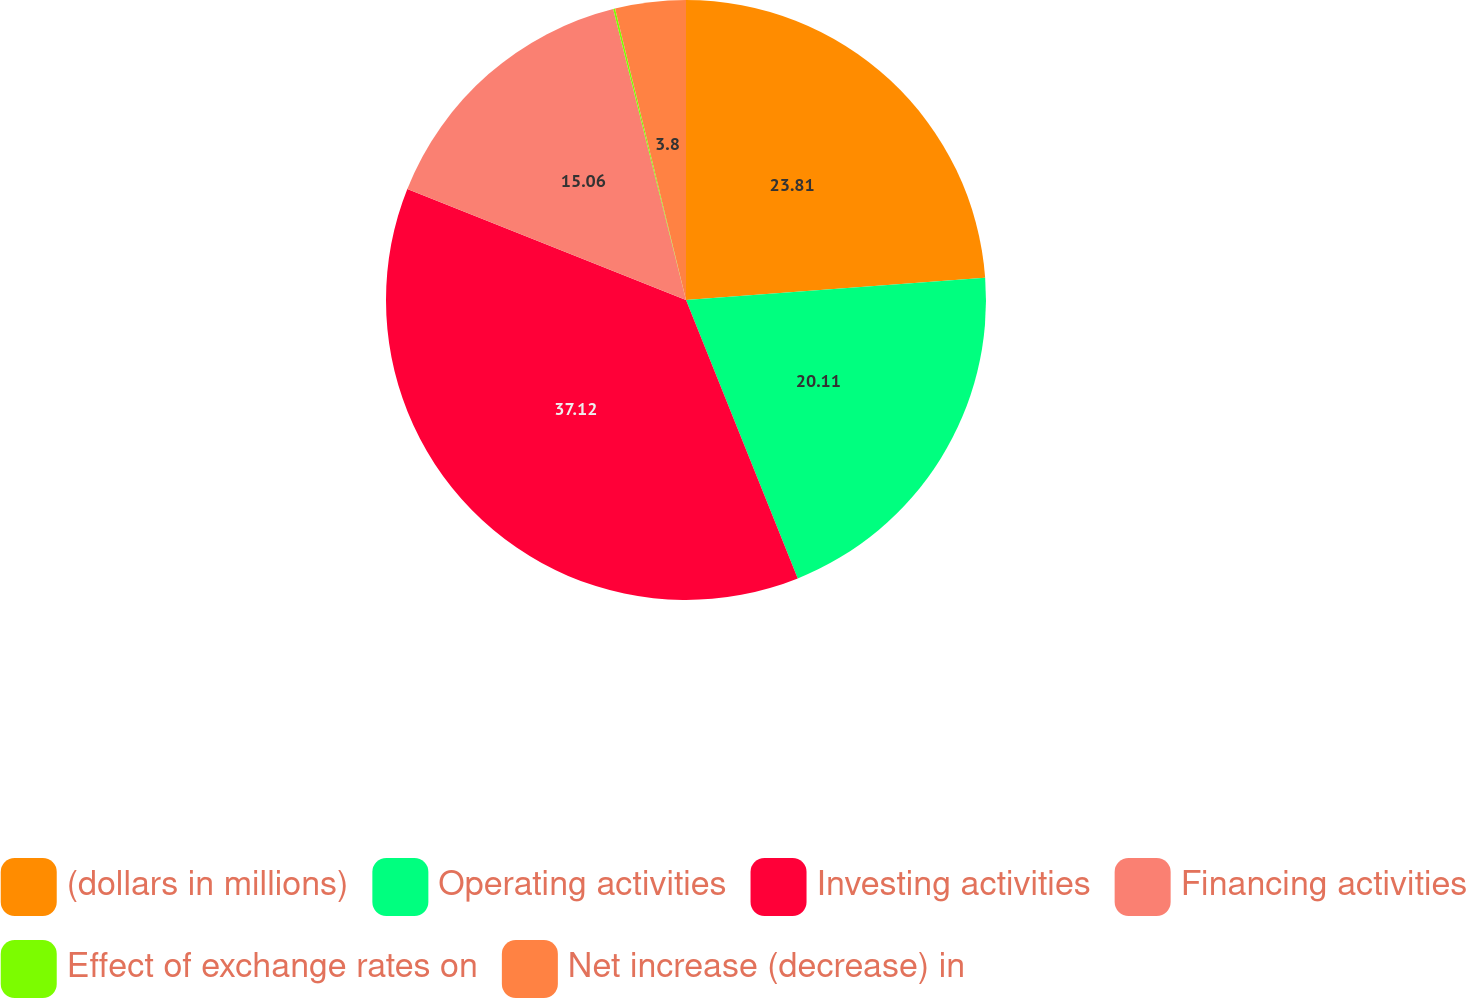<chart> <loc_0><loc_0><loc_500><loc_500><pie_chart><fcel>(dollars in millions)<fcel>Operating activities<fcel>Investing activities<fcel>Financing activities<fcel>Effect of exchange rates on<fcel>Net increase (decrease) in<nl><fcel>23.81%<fcel>20.11%<fcel>37.11%<fcel>15.06%<fcel>0.1%<fcel>3.8%<nl></chart> 